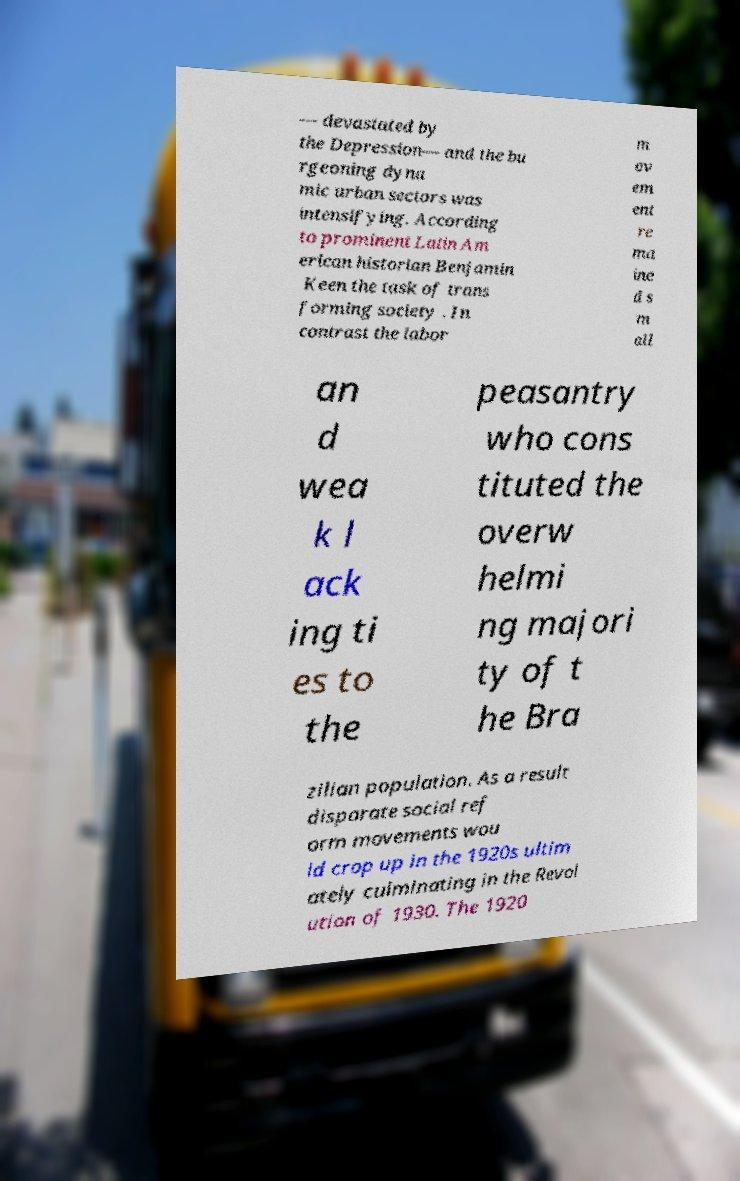What messages or text are displayed in this image? I need them in a readable, typed format. — devastated by the Depression— and the bu rgeoning dyna mic urban sectors was intensifying. According to prominent Latin Am erican historian Benjamin Keen the task of trans forming society . In contrast the labor m ov em ent re ma ine d s m all an d wea k l ack ing ti es to the peasantry who cons tituted the overw helmi ng majori ty of t he Bra zilian population. As a result disparate social ref orm movements wou ld crop up in the 1920s ultim ately culminating in the Revol ution of 1930. The 1920 